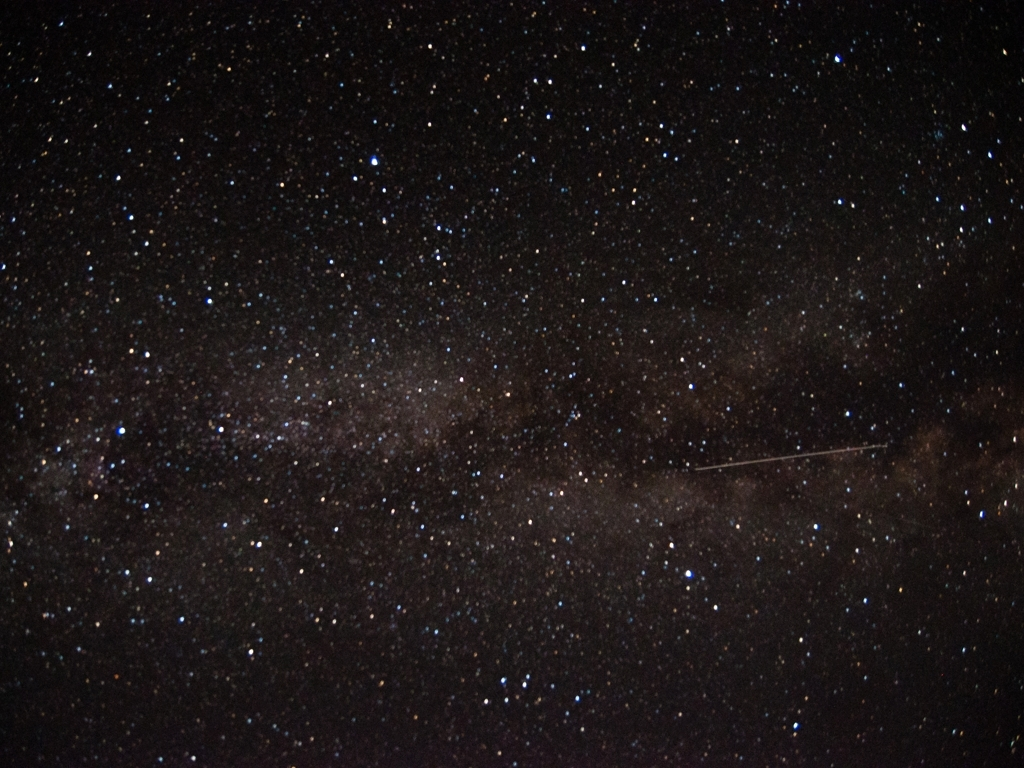How monotonous is the background of the image?
A. Somewhat
B. Extremely
C. Not at all While the image depicts a starry sky with variations in star density and brightness, which some may find subtly varied rather than monotonous, others may consider the consistent dark backdrop and lack of distinguishable features as somewhat monotonous. Therefore, a more nuanced answer than option 'A. Somewhat' is, 'The starry background provides a natural variation due to the differing intensity and distribution of stars, offering a sense of depth and space, which can be perceived as moderately monotonous to an observer looking for more distinct features or subjects.' 